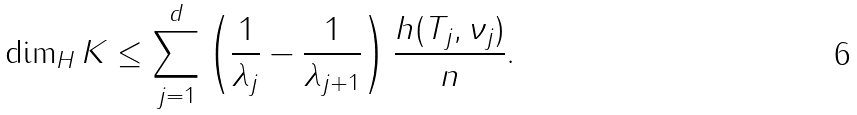Convert formula to latex. <formula><loc_0><loc_0><loc_500><loc_500>\dim _ { H } K \leq \sum _ { j = 1 } ^ { d } \left ( \frac { 1 } { \lambda _ { j } } - \frac { 1 } { \lambda _ { j + 1 } } \right ) \frac { h ( T _ { j } , \nu _ { j } ) } { n } .</formula> 